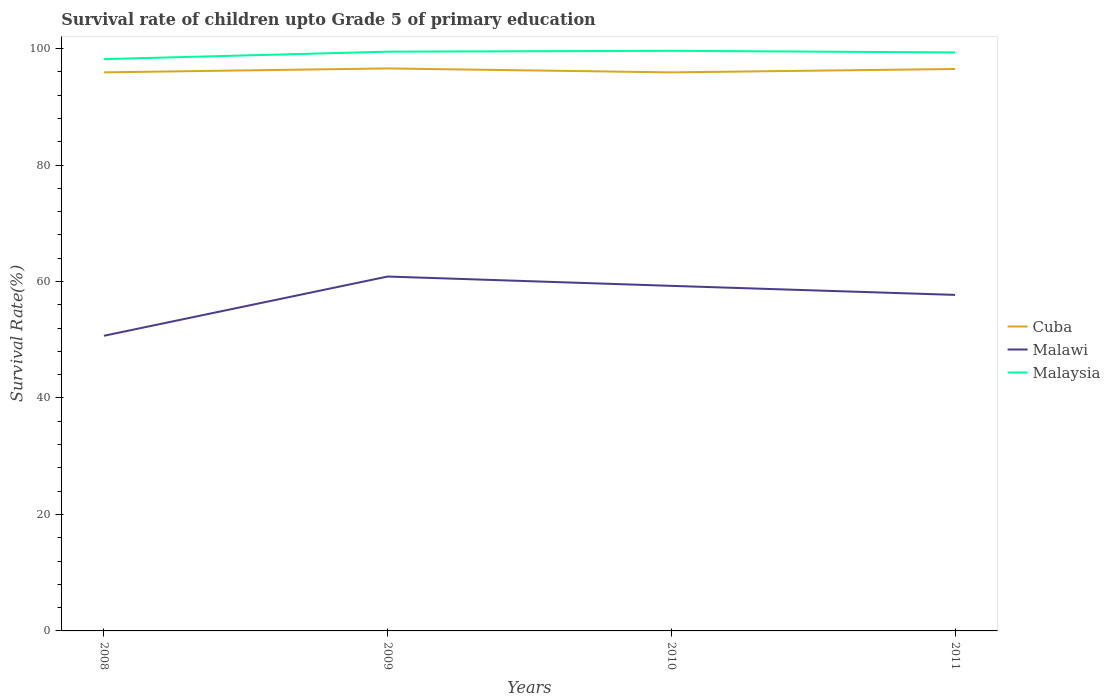How many different coloured lines are there?
Your response must be concise. 3. Does the line corresponding to Malawi intersect with the line corresponding to Cuba?
Keep it short and to the point. No. Across all years, what is the maximum survival rate of children in Malaysia?
Keep it short and to the point. 98.19. What is the total survival rate of children in Cuba in the graph?
Give a very brief answer. 0. What is the difference between the highest and the second highest survival rate of children in Malawi?
Provide a short and direct response. 10.17. Is the survival rate of children in Malaysia strictly greater than the survival rate of children in Cuba over the years?
Make the answer very short. No. How many lines are there?
Make the answer very short. 3. Are the values on the major ticks of Y-axis written in scientific E-notation?
Ensure brevity in your answer.  No. Where does the legend appear in the graph?
Give a very brief answer. Center right. How are the legend labels stacked?
Make the answer very short. Vertical. What is the title of the graph?
Provide a succinct answer. Survival rate of children upto Grade 5 of primary education. What is the label or title of the Y-axis?
Provide a short and direct response. Survival Rate(%). What is the Survival Rate(%) of Cuba in 2008?
Keep it short and to the point. 95.92. What is the Survival Rate(%) in Malawi in 2008?
Provide a short and direct response. 50.69. What is the Survival Rate(%) of Malaysia in 2008?
Give a very brief answer. 98.19. What is the Survival Rate(%) of Cuba in 2009?
Provide a succinct answer. 96.6. What is the Survival Rate(%) of Malawi in 2009?
Make the answer very short. 60.86. What is the Survival Rate(%) of Malaysia in 2009?
Provide a short and direct response. 99.47. What is the Survival Rate(%) of Cuba in 2010?
Provide a short and direct response. 95.92. What is the Survival Rate(%) in Malawi in 2010?
Keep it short and to the point. 59.26. What is the Survival Rate(%) in Malaysia in 2010?
Make the answer very short. 99.62. What is the Survival Rate(%) of Cuba in 2011?
Ensure brevity in your answer.  96.5. What is the Survival Rate(%) in Malawi in 2011?
Keep it short and to the point. 57.71. What is the Survival Rate(%) of Malaysia in 2011?
Make the answer very short. 99.35. Across all years, what is the maximum Survival Rate(%) of Cuba?
Your response must be concise. 96.6. Across all years, what is the maximum Survival Rate(%) in Malawi?
Keep it short and to the point. 60.86. Across all years, what is the maximum Survival Rate(%) in Malaysia?
Make the answer very short. 99.62. Across all years, what is the minimum Survival Rate(%) of Cuba?
Offer a terse response. 95.92. Across all years, what is the minimum Survival Rate(%) of Malawi?
Keep it short and to the point. 50.69. Across all years, what is the minimum Survival Rate(%) of Malaysia?
Give a very brief answer. 98.19. What is the total Survival Rate(%) in Cuba in the graph?
Give a very brief answer. 384.94. What is the total Survival Rate(%) of Malawi in the graph?
Your answer should be compact. 228.51. What is the total Survival Rate(%) of Malaysia in the graph?
Give a very brief answer. 396.63. What is the difference between the Survival Rate(%) in Cuba in 2008 and that in 2009?
Your answer should be very brief. -0.68. What is the difference between the Survival Rate(%) in Malawi in 2008 and that in 2009?
Your answer should be compact. -10.17. What is the difference between the Survival Rate(%) of Malaysia in 2008 and that in 2009?
Your answer should be very brief. -1.28. What is the difference between the Survival Rate(%) of Cuba in 2008 and that in 2010?
Your answer should be very brief. 0. What is the difference between the Survival Rate(%) in Malawi in 2008 and that in 2010?
Your answer should be very brief. -8.57. What is the difference between the Survival Rate(%) in Malaysia in 2008 and that in 2010?
Offer a very short reply. -1.43. What is the difference between the Survival Rate(%) in Cuba in 2008 and that in 2011?
Offer a terse response. -0.58. What is the difference between the Survival Rate(%) in Malawi in 2008 and that in 2011?
Offer a terse response. -7.02. What is the difference between the Survival Rate(%) of Malaysia in 2008 and that in 2011?
Offer a very short reply. -1.15. What is the difference between the Survival Rate(%) of Cuba in 2009 and that in 2010?
Your answer should be compact. 0.68. What is the difference between the Survival Rate(%) of Malawi in 2009 and that in 2010?
Ensure brevity in your answer.  1.6. What is the difference between the Survival Rate(%) of Malaysia in 2009 and that in 2010?
Offer a terse response. -0.15. What is the difference between the Survival Rate(%) of Cuba in 2009 and that in 2011?
Make the answer very short. 0.1. What is the difference between the Survival Rate(%) of Malawi in 2009 and that in 2011?
Keep it short and to the point. 3.15. What is the difference between the Survival Rate(%) in Malaysia in 2009 and that in 2011?
Give a very brief answer. 0.13. What is the difference between the Survival Rate(%) in Cuba in 2010 and that in 2011?
Make the answer very short. -0.58. What is the difference between the Survival Rate(%) in Malawi in 2010 and that in 2011?
Offer a terse response. 1.55. What is the difference between the Survival Rate(%) of Malaysia in 2010 and that in 2011?
Your answer should be very brief. 0.27. What is the difference between the Survival Rate(%) in Cuba in 2008 and the Survival Rate(%) in Malawi in 2009?
Offer a very short reply. 35.06. What is the difference between the Survival Rate(%) in Cuba in 2008 and the Survival Rate(%) in Malaysia in 2009?
Offer a terse response. -3.55. What is the difference between the Survival Rate(%) in Malawi in 2008 and the Survival Rate(%) in Malaysia in 2009?
Ensure brevity in your answer.  -48.79. What is the difference between the Survival Rate(%) of Cuba in 2008 and the Survival Rate(%) of Malawi in 2010?
Provide a short and direct response. 36.66. What is the difference between the Survival Rate(%) of Cuba in 2008 and the Survival Rate(%) of Malaysia in 2010?
Provide a succinct answer. -3.7. What is the difference between the Survival Rate(%) of Malawi in 2008 and the Survival Rate(%) of Malaysia in 2010?
Offer a very short reply. -48.93. What is the difference between the Survival Rate(%) in Cuba in 2008 and the Survival Rate(%) in Malawi in 2011?
Offer a terse response. 38.21. What is the difference between the Survival Rate(%) of Cuba in 2008 and the Survival Rate(%) of Malaysia in 2011?
Keep it short and to the point. -3.43. What is the difference between the Survival Rate(%) of Malawi in 2008 and the Survival Rate(%) of Malaysia in 2011?
Keep it short and to the point. -48.66. What is the difference between the Survival Rate(%) in Cuba in 2009 and the Survival Rate(%) in Malawi in 2010?
Give a very brief answer. 37.34. What is the difference between the Survival Rate(%) in Cuba in 2009 and the Survival Rate(%) in Malaysia in 2010?
Offer a terse response. -3.02. What is the difference between the Survival Rate(%) in Malawi in 2009 and the Survival Rate(%) in Malaysia in 2010?
Offer a terse response. -38.76. What is the difference between the Survival Rate(%) of Cuba in 2009 and the Survival Rate(%) of Malawi in 2011?
Your answer should be very brief. 38.89. What is the difference between the Survival Rate(%) in Cuba in 2009 and the Survival Rate(%) in Malaysia in 2011?
Give a very brief answer. -2.75. What is the difference between the Survival Rate(%) in Malawi in 2009 and the Survival Rate(%) in Malaysia in 2011?
Offer a terse response. -38.49. What is the difference between the Survival Rate(%) of Cuba in 2010 and the Survival Rate(%) of Malawi in 2011?
Your answer should be compact. 38.21. What is the difference between the Survival Rate(%) in Cuba in 2010 and the Survival Rate(%) in Malaysia in 2011?
Keep it short and to the point. -3.43. What is the difference between the Survival Rate(%) in Malawi in 2010 and the Survival Rate(%) in Malaysia in 2011?
Ensure brevity in your answer.  -40.09. What is the average Survival Rate(%) in Cuba per year?
Ensure brevity in your answer.  96.23. What is the average Survival Rate(%) in Malawi per year?
Provide a succinct answer. 57.13. What is the average Survival Rate(%) of Malaysia per year?
Your answer should be very brief. 99.16. In the year 2008, what is the difference between the Survival Rate(%) in Cuba and Survival Rate(%) in Malawi?
Your response must be concise. 45.23. In the year 2008, what is the difference between the Survival Rate(%) of Cuba and Survival Rate(%) of Malaysia?
Offer a terse response. -2.27. In the year 2008, what is the difference between the Survival Rate(%) in Malawi and Survival Rate(%) in Malaysia?
Offer a terse response. -47.51. In the year 2009, what is the difference between the Survival Rate(%) of Cuba and Survival Rate(%) of Malawi?
Offer a very short reply. 35.74. In the year 2009, what is the difference between the Survival Rate(%) in Cuba and Survival Rate(%) in Malaysia?
Your answer should be very brief. -2.88. In the year 2009, what is the difference between the Survival Rate(%) of Malawi and Survival Rate(%) of Malaysia?
Provide a short and direct response. -38.61. In the year 2010, what is the difference between the Survival Rate(%) of Cuba and Survival Rate(%) of Malawi?
Offer a very short reply. 36.66. In the year 2010, what is the difference between the Survival Rate(%) of Cuba and Survival Rate(%) of Malaysia?
Offer a terse response. -3.7. In the year 2010, what is the difference between the Survival Rate(%) of Malawi and Survival Rate(%) of Malaysia?
Your answer should be very brief. -40.36. In the year 2011, what is the difference between the Survival Rate(%) of Cuba and Survival Rate(%) of Malawi?
Offer a terse response. 38.79. In the year 2011, what is the difference between the Survival Rate(%) of Cuba and Survival Rate(%) of Malaysia?
Provide a short and direct response. -2.85. In the year 2011, what is the difference between the Survival Rate(%) of Malawi and Survival Rate(%) of Malaysia?
Your answer should be very brief. -41.64. What is the ratio of the Survival Rate(%) in Cuba in 2008 to that in 2009?
Keep it short and to the point. 0.99. What is the ratio of the Survival Rate(%) of Malawi in 2008 to that in 2009?
Make the answer very short. 0.83. What is the ratio of the Survival Rate(%) of Malaysia in 2008 to that in 2009?
Your answer should be very brief. 0.99. What is the ratio of the Survival Rate(%) of Cuba in 2008 to that in 2010?
Make the answer very short. 1. What is the ratio of the Survival Rate(%) of Malawi in 2008 to that in 2010?
Ensure brevity in your answer.  0.86. What is the ratio of the Survival Rate(%) in Malaysia in 2008 to that in 2010?
Give a very brief answer. 0.99. What is the ratio of the Survival Rate(%) in Malawi in 2008 to that in 2011?
Make the answer very short. 0.88. What is the ratio of the Survival Rate(%) in Malaysia in 2008 to that in 2011?
Your response must be concise. 0.99. What is the ratio of the Survival Rate(%) in Cuba in 2009 to that in 2010?
Provide a succinct answer. 1.01. What is the ratio of the Survival Rate(%) in Malawi in 2009 to that in 2010?
Offer a terse response. 1.03. What is the ratio of the Survival Rate(%) in Malawi in 2009 to that in 2011?
Provide a short and direct response. 1.05. What is the ratio of the Survival Rate(%) of Malaysia in 2009 to that in 2011?
Provide a short and direct response. 1. What is the ratio of the Survival Rate(%) of Cuba in 2010 to that in 2011?
Provide a short and direct response. 0.99. What is the ratio of the Survival Rate(%) in Malawi in 2010 to that in 2011?
Offer a terse response. 1.03. What is the ratio of the Survival Rate(%) in Malaysia in 2010 to that in 2011?
Keep it short and to the point. 1. What is the difference between the highest and the second highest Survival Rate(%) of Cuba?
Your answer should be very brief. 0.1. What is the difference between the highest and the second highest Survival Rate(%) of Malawi?
Your answer should be compact. 1.6. What is the difference between the highest and the second highest Survival Rate(%) in Malaysia?
Your answer should be compact. 0.15. What is the difference between the highest and the lowest Survival Rate(%) in Cuba?
Keep it short and to the point. 0.68. What is the difference between the highest and the lowest Survival Rate(%) of Malawi?
Your response must be concise. 10.17. What is the difference between the highest and the lowest Survival Rate(%) of Malaysia?
Keep it short and to the point. 1.43. 